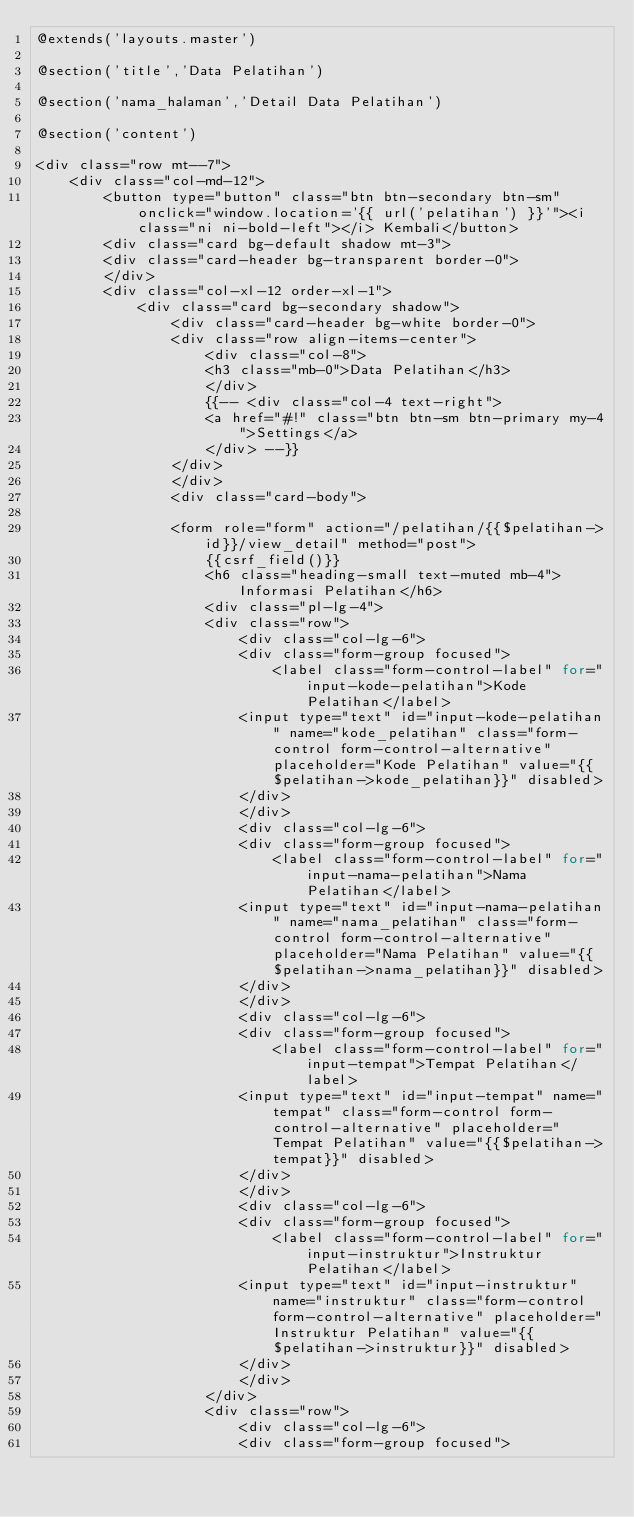Convert code to text. <code><loc_0><loc_0><loc_500><loc_500><_PHP_>@extends('layouts.master')

@section('title','Data Pelatihan')

@section('nama_halaman','Detail Data Pelatihan')

@section('content')

<div class="row mt--7"> 
    <div class="col-md-12">
        <button type="button" class="btn btn-secondary btn-sm" onclick="window.location='{{ url('pelatihan') }}'"><i class="ni ni-bold-left"></i> Kembali</button>
        <div class="card bg-default shadow mt-3">
        <div class="card-header bg-transparent border-0">
        </div>
        <div class="col-xl-12 order-xl-1">
            <div class="card bg-secondary shadow">
                <div class="card-header bg-white border-0">
                <div class="row align-items-center">
                    <div class="col-8">
                    <h3 class="mb-0">Data Pelatihan</h3>
                    </div>
                    {{-- <div class="col-4 text-right">
                    <a href="#!" class="btn btn-sm btn-primary my-4">Settings</a>
                    </div> --}}
                </div>
                </div>
                <div class="card-body">

                <form role="form" action="/pelatihan/{{$pelatihan->id}}/view_detail" method="post">
                    {{csrf_field()}}
                    <h6 class="heading-small text-muted mb-4">Informasi Pelatihan</h6>                                                                                
                    <div class="pl-lg-4">
                    <div class="row">
                        <div class="col-lg-6">
                        <div class="form-group focused">
                            <label class="form-control-label" for="input-kode-pelatihan">Kode Pelatihan</label>
                        <input type="text" id="input-kode-pelatihan" name="kode_pelatihan" class="form-control form-control-alternative" placeholder="Kode Pelatihan" value="{{$pelatihan->kode_pelatihan}}" disabled>
                        </div>
                        </div>
                        <div class="col-lg-6">
                        <div class="form-group focused">
                            <label class="form-control-label" for="input-nama-pelatihan">Nama Pelatihan</label>
                        <input type="text" id="input-nama-pelatihan" name="nama_pelatihan" class="form-control form-control-alternative" placeholder="Nama Pelatihan" value="{{$pelatihan->nama_pelatihan}}" disabled>
                        </div>
                        </div>
                        <div class="col-lg-6">
                        <div class="form-group focused">
                            <label class="form-control-label" for="input-tempat">Tempat Pelatihan</label>
                        <input type="text" id="input-tempat" name="tempat" class="form-control form-control-alternative" placeholder="Tempat Pelatihan" value="{{$pelatihan->tempat}}" disabled>
                        </div>
                        </div>
                        <div class="col-lg-6">
                        <div class="form-group focused">
                            <label class="form-control-label" for="input-instruktur">Instruktur Pelatihan</label>
                        <input type="text" id="input-instruktur" name="instruktur" class="form-control form-control-alternative" placeholder="Instruktur Pelatihan" value="{{$pelatihan->instruktur}}" disabled>
                        </div>
                        </div>                  
                    </div>
                    <div class="row">
                        <div class="col-lg-6">
                        <div class="form-group focused"></code> 